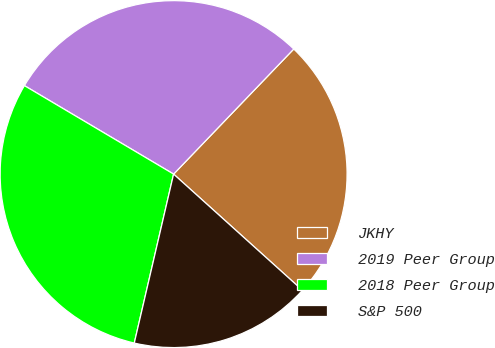Convert chart. <chart><loc_0><loc_0><loc_500><loc_500><pie_chart><fcel>JKHY<fcel>2019 Peer Group<fcel>2018 Peer Group<fcel>S&P 500<nl><fcel>24.5%<fcel>28.66%<fcel>29.88%<fcel>16.96%<nl></chart> 